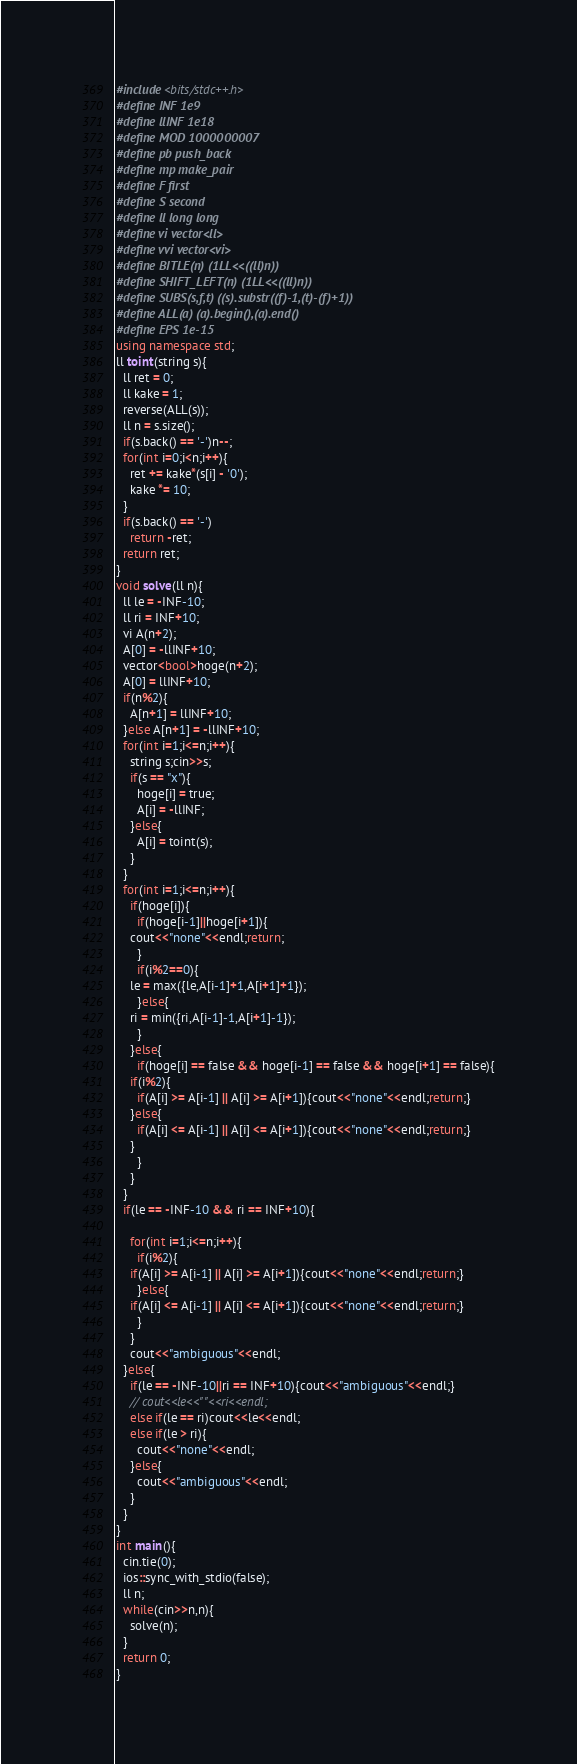<code> <loc_0><loc_0><loc_500><loc_500><_C++_>#include<bits/stdc++.h>
#define INF 1e9
#define llINF 1e18
#define MOD 1000000007
#define pb push_back
#define mp make_pair 
#define F first
#define S second
#define ll long long
#define vi vector<ll>
#define vvi vector<vi>
#define BITLE(n) (1LL<<((ll)n))
#define SHIFT_LEFT(n) (1LL<<((ll)n))
#define SUBS(s,f,t) ((s).substr((f)-1,(t)-(f)+1))
#define ALL(a) (a).begin(),(a).end()
#define EPS 1e-15
using namespace std;
ll toint(string s){
  ll ret = 0;
  ll kake = 1;
  reverse(ALL(s));
  ll n = s.size();
  if(s.back() == '-')n--;
  for(int i=0;i<n;i++){
    ret += kake*(s[i] - '0');
    kake *= 10;
  }
  if(s.back() == '-')
    return -ret;
  return ret;
}
void solve(ll n){
  ll le = -INF-10;
  ll ri = INF+10;
  vi A(n+2);
  A[0] = -llINF+10;
  vector<bool>hoge(n+2);
  A[0] = llINF+10;
  if(n%2){
    A[n+1] = llINF+10;
  }else A[n+1] = -llINF+10;
  for(int i=1;i<=n;i++){
    string s;cin>>s;
    if(s == "x"){
      hoge[i] = true;
      A[i] = -llINF;
    }else{
      A[i] = toint(s);
    }
  }
  for(int i=1;i<=n;i++){
    if(hoge[i]){
      if(hoge[i-1]||hoge[i+1]){
	cout<<"none"<<endl;return;
      }
      if(i%2==0){
	le = max({le,A[i-1]+1,A[i+1]+1});
      }else{
	ri = min({ri,A[i-1]-1,A[i+1]-1});
      }
    }else{
      if(hoge[i] == false && hoge[i-1] == false && hoge[i+1] == false){
	if(i%2){
	  if(A[i] >= A[i-1] || A[i] >= A[i+1]){cout<<"none"<<endl;return;}
	}else{
	  if(A[i] <= A[i-1] || A[i] <= A[i+1]){cout<<"none"<<endl;return;}
	}
      }
    }
  }
  if(le == -INF-10 && ri == INF+10){
 
    for(int i=1;i<=n;i++){
      if(i%2){
	if(A[i] >= A[i-1] || A[i] >= A[i+1]){cout<<"none"<<endl;return;}
      }else{
	if(A[i] <= A[i-1] || A[i] <= A[i+1]){cout<<"none"<<endl;return;}
      }
    }
    cout<<"ambiguous"<<endl;
  }else{
    if(le == -INF-10||ri == INF+10){cout<<"ambiguous"<<endl;}
    // cout<<le<<" "<<ri<<endl;
    else if(le == ri)cout<<le<<endl;
    else if(le > ri){
      cout<<"none"<<endl;
    }else{
      cout<<"ambiguous"<<endl;
    }
  }
}
int main(){
  cin.tie(0);
  ios::sync_with_stdio(false);
  ll n;
  while(cin>>n,n){
    solve(n);
  }
  return 0;
}

</code> 